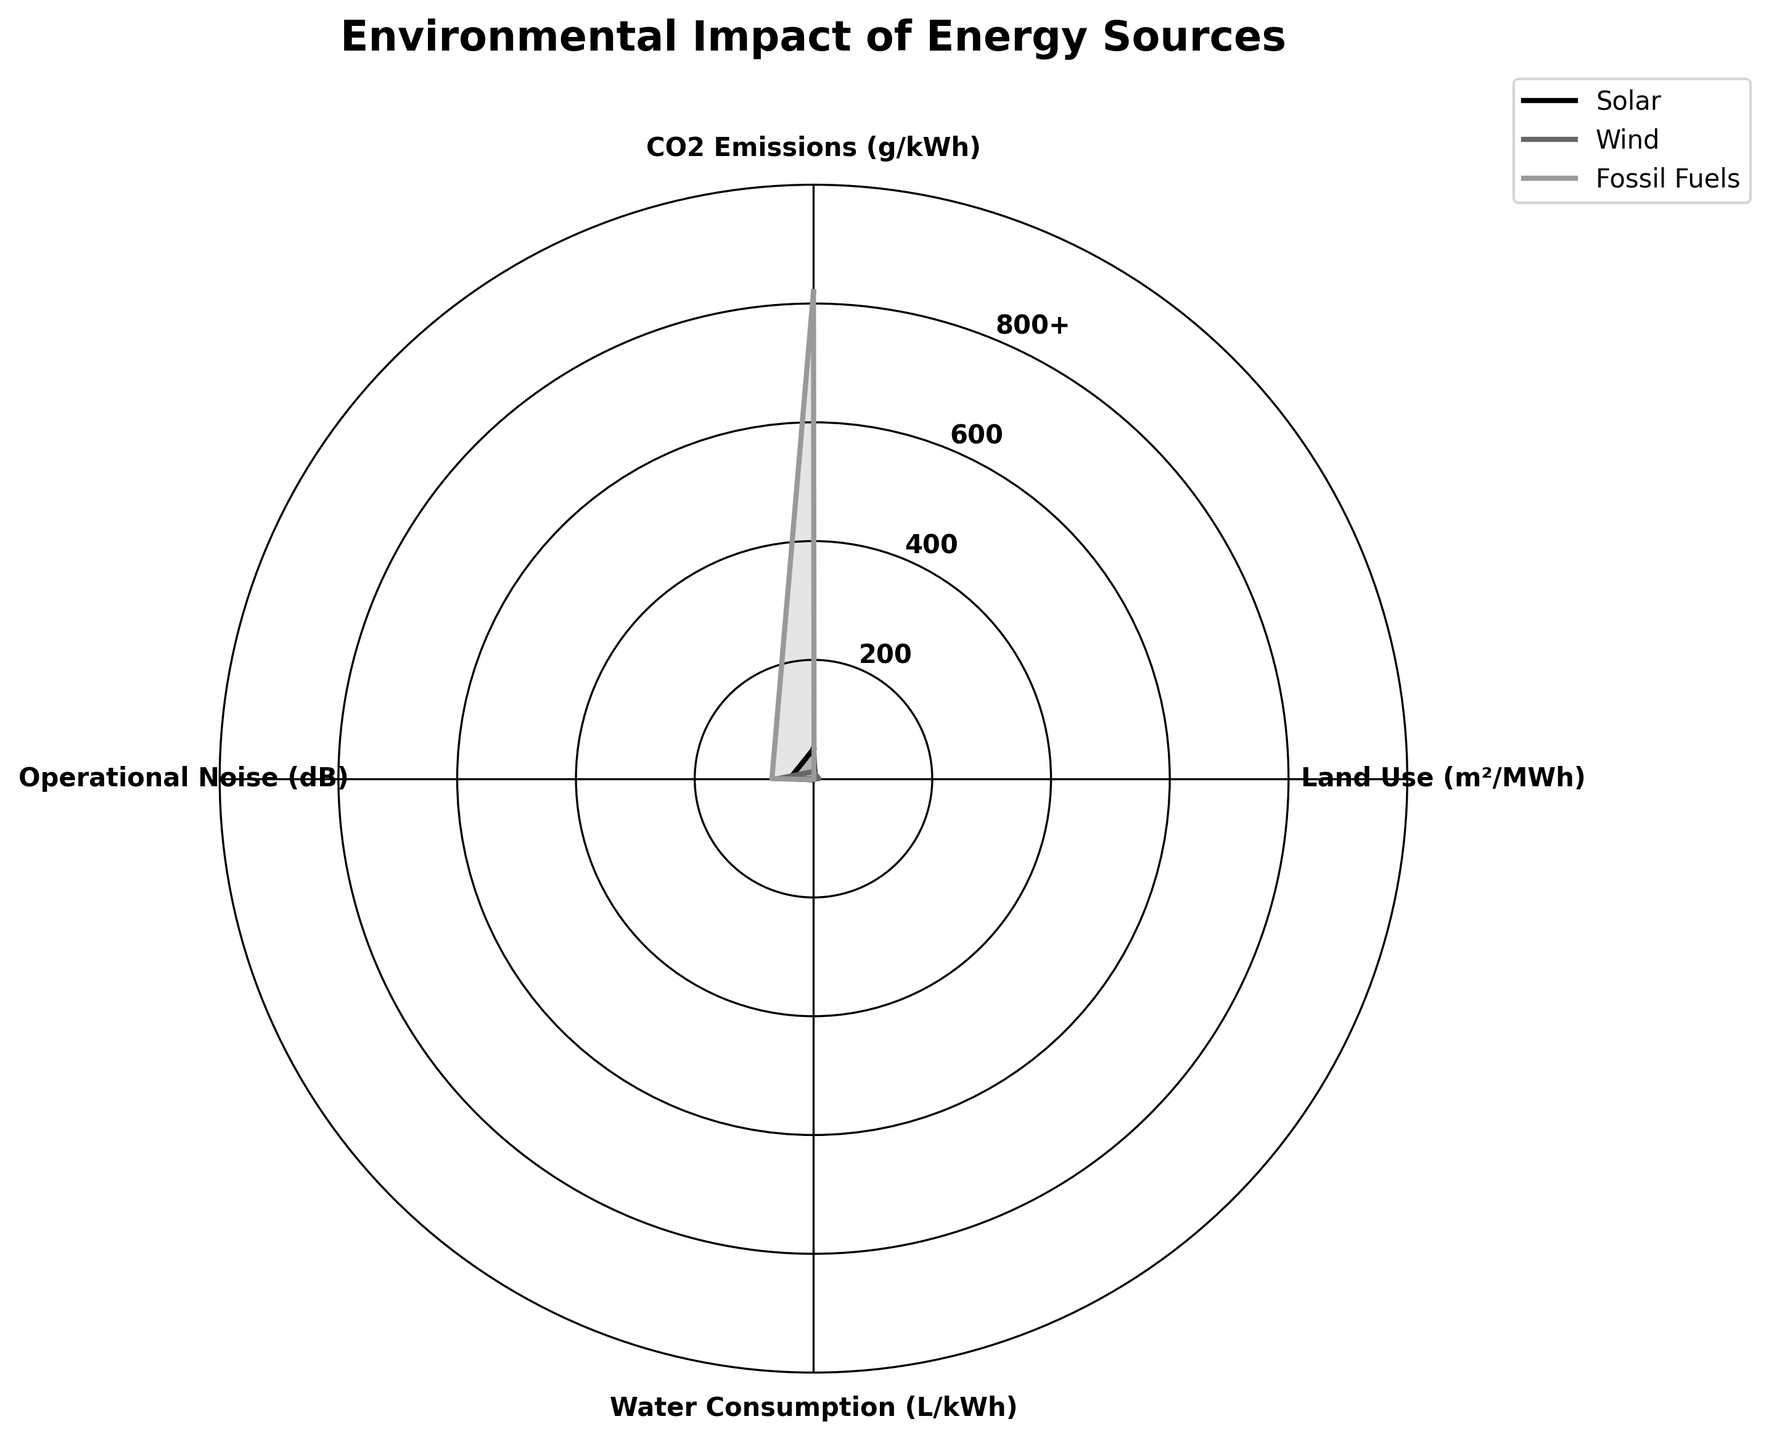What is the title of the radar chart? The title of the radar chart is usually placed prominently at the top of the figure. For this radar chart, the title is placed at the very top and reads 'Environmental Impact of Energy Sources'.
Answer: Environmental Impact of Energy Sources How many categories are there in the radar chart? To determine the number of categories, look at the number of axes radiating from the center of the radar chart. There are four axes labeled 'CO2 Emissions', 'Land Use', 'Water Consumption', and 'Operational Noise'.
Answer: Four Which energy source has the highest CO2 emissions? By inspecting the 'CO2 Emissions' axis, we see that the data point for 'Fossil Fuels' is the farthest from the center, indicating the highest value among the energy sources.
Answer: Fossil Fuels How do Wind and Solar compare in terms of Land Use? Observe the 'Land Use' axis. The data point for 'Wind' is farther from the center compared to 'Solar', indicating that Wind has a higher land use per MWh.
Answer: Wind uses more land Rank the energy sources from least to most water consumption. To rank the energy sources by water consumption, look at the 'Water Consumption' axis. The closest to the center is Wind, followed by Fossil Fuels, and then Solar, which is the farthest. Therefore, in ascending order: Wind, Fossil Fuels, Solar.
Answer: Wind, Fossil Fuels, Solar Which energy source has the quietest operational noise? Check the 'Operational Noise' axis and find the value closest to the center. The data point for 'Solar' is the closest, indicating it has the lowest (quietest) operational noise.
Answer: Solar What is the total CO2 emissions of all energy sources combined? Sum the CO2 emission values from each energy source: Solar (50 g/kWh), Wind (12 g/kWh), and Fossil Fuels (820 g/kWh). The total is 50 + 12 + 820.
Answer: 882 g/kWh Is the land use for Solar greater than Wind? To compare, look at the 'Land Use' axis. The data point for Solar is closer to the center compared to Wind, indicating Solar uses less land than Wind.
Answer: No, Solar uses less land By how much does Fossil Fuels exceed Wind in terms of CO2 emissions? Observe the 'CO2 Emissions' axis and subtract Wind's value (12 g/kWh) from Fossil Fuels' value (820 g/kWh). The difference is 820 - 12.
Answer: 808 g/kWh Which energy source performs the best across all environmental parameters? The best-performing energy source would generally have data points closest to the center for all categories. Wind has the lowest values for CO2 emissions and water consumption, and a moderate value for land use. Solar performs well in terms of noise and CO2 emissions but uses more water than Wind. Fossil Fuels perform the worst overall. Combining all aspects, Wind performs the best overall.
Answer: Wind 